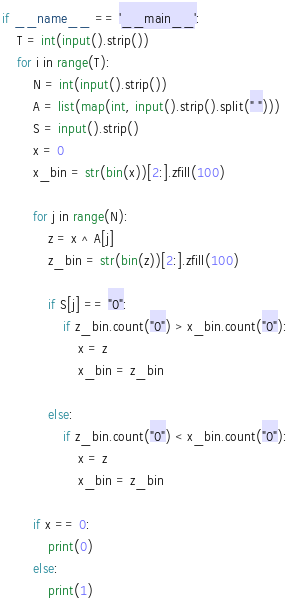Convert code to text. <code><loc_0><loc_0><loc_500><loc_500><_Python_>if __name__ == '__main__':
    T = int(input().strip())
    for i in range(T):
        N = int(input().strip())
        A = list(map(int, input().strip().split(" ")))
        S = input().strip()
        x = 0
        x_bin = str(bin(x))[2:].zfill(100)

        for j in range(N):
            z = x ^ A[j]
            z_bin = str(bin(z))[2:].zfill(100)

            if S[j] == "0":
                if z_bin.count("0") > x_bin.count("0"):
                    x = z
                    x_bin = z_bin

            else:
                if z_bin.count("0") < x_bin.count("0"):
                    x = z
                    x_bin = z_bin

        if x == 0:
            print(0)
        else:
            print(1)</code> 